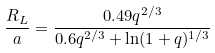Convert formula to latex. <formula><loc_0><loc_0><loc_500><loc_500>\frac { R _ { L } } { a } = \frac { 0 . 4 9 q ^ { 2 / 3 } } { 0 . 6 q ^ { 2 / 3 } + \ln ( 1 + q ) ^ { 1 / 3 } }</formula> 